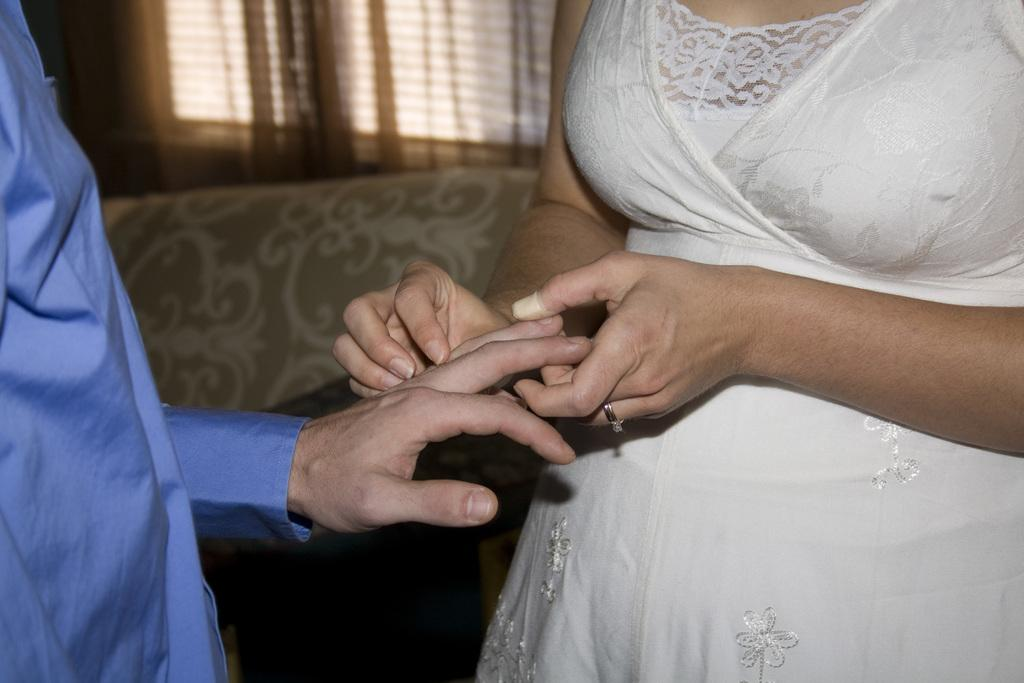How many people are in the image? There are two persons in the foreground of the image. What are the two persons doing? The two persons are holding hands. What can be seen in the background of the image? There is a window in the background of the image. Is there any window treatment present in the image? Yes, there is a curtain associated with the window. What type of root can be seen growing through the floor in the image? There is no root visible in the image; it features two persons holding hands in the foreground and a window with a curtain in the background. 